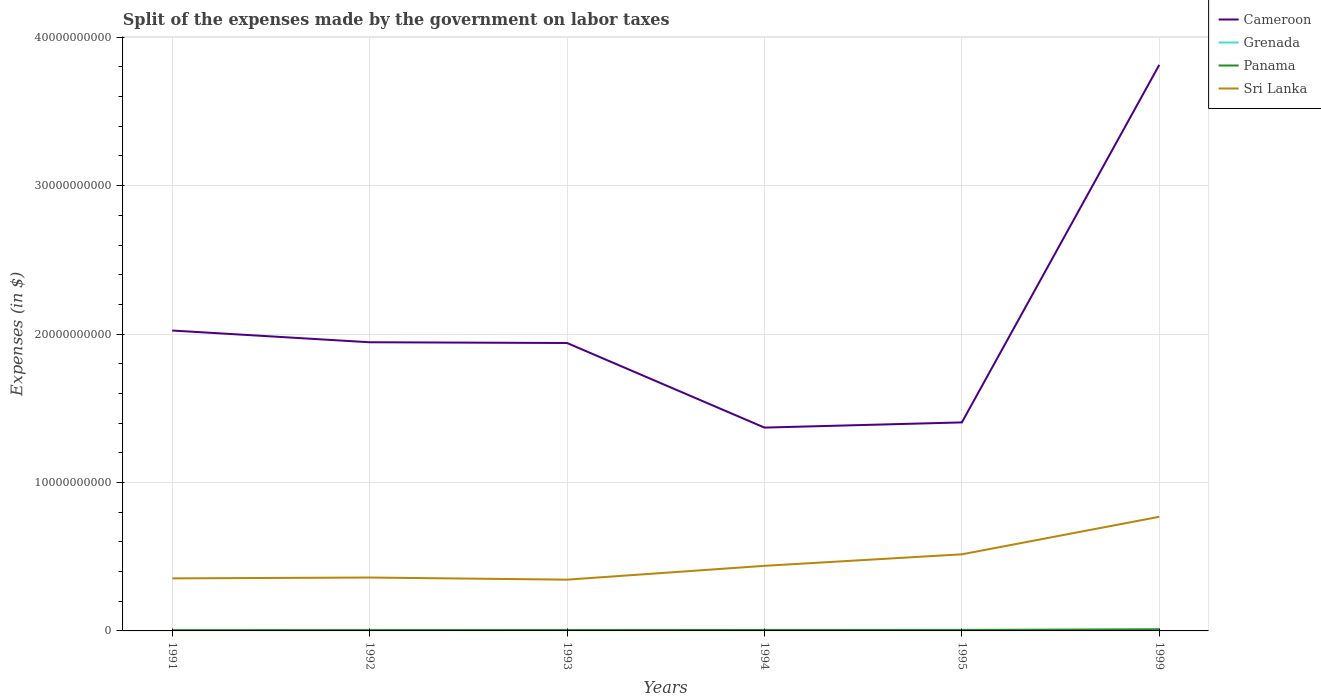How many different coloured lines are there?
Your answer should be very brief. 4. Across all years, what is the maximum expenses made by the government on labor taxes in Sri Lanka?
Your answer should be compact. 3.45e+09. What is the total expenses made by the government on labor taxes in Panama in the graph?
Give a very brief answer. -2.40e+06. What is the difference between the highest and the second highest expenses made by the government on labor taxes in Grenada?
Your response must be concise. 4.68e+06. What is the difference between the highest and the lowest expenses made by the government on labor taxes in Sri Lanka?
Provide a succinct answer. 2. How many years are there in the graph?
Your response must be concise. 6. How many legend labels are there?
Your answer should be very brief. 4. What is the title of the graph?
Offer a terse response. Split of the expenses made by the government on labor taxes. Does "Vietnam" appear as one of the legend labels in the graph?
Provide a succinct answer. No. What is the label or title of the X-axis?
Offer a very short reply. Years. What is the label or title of the Y-axis?
Provide a short and direct response. Expenses (in $). What is the Expenses (in $) in Cameroon in 1991?
Ensure brevity in your answer.  2.02e+1. What is the Expenses (in $) of Grenada in 1991?
Your answer should be compact. 6.36e+06. What is the Expenses (in $) of Panama in 1991?
Make the answer very short. 5.18e+07. What is the Expenses (in $) in Sri Lanka in 1991?
Your answer should be very brief. 3.54e+09. What is the Expenses (in $) of Cameroon in 1992?
Give a very brief answer. 1.94e+1. What is the Expenses (in $) of Grenada in 1992?
Your answer should be very brief. 5.82e+06. What is the Expenses (in $) in Panama in 1992?
Your answer should be compact. 5.61e+07. What is the Expenses (in $) of Sri Lanka in 1992?
Keep it short and to the point. 3.60e+09. What is the Expenses (in $) in Cameroon in 1993?
Your answer should be compact. 1.94e+1. What is the Expenses (in $) in Grenada in 1993?
Give a very brief answer. 8.93e+06. What is the Expenses (in $) in Panama in 1993?
Your answer should be compact. 5.89e+07. What is the Expenses (in $) in Sri Lanka in 1993?
Keep it short and to the point. 3.45e+09. What is the Expenses (in $) of Cameroon in 1994?
Keep it short and to the point. 1.37e+1. What is the Expenses (in $) of Grenada in 1994?
Ensure brevity in your answer.  9.53e+06. What is the Expenses (in $) in Panama in 1994?
Provide a succinct answer. 6.34e+07. What is the Expenses (in $) of Sri Lanka in 1994?
Provide a short and direct response. 4.39e+09. What is the Expenses (in $) in Cameroon in 1995?
Give a very brief answer. 1.40e+1. What is the Expenses (in $) in Grenada in 1995?
Keep it short and to the point. 9.49e+06. What is the Expenses (in $) in Panama in 1995?
Your response must be concise. 6.58e+07. What is the Expenses (in $) in Sri Lanka in 1995?
Give a very brief answer. 5.16e+09. What is the Expenses (in $) in Cameroon in 1999?
Make the answer very short. 3.81e+1. What is the Expenses (in $) in Grenada in 1999?
Make the answer very short. 1.05e+07. What is the Expenses (in $) in Panama in 1999?
Provide a short and direct response. 1.11e+08. What is the Expenses (in $) in Sri Lanka in 1999?
Your response must be concise. 7.69e+09. Across all years, what is the maximum Expenses (in $) of Cameroon?
Your answer should be very brief. 3.81e+1. Across all years, what is the maximum Expenses (in $) of Grenada?
Provide a short and direct response. 1.05e+07. Across all years, what is the maximum Expenses (in $) of Panama?
Your response must be concise. 1.11e+08. Across all years, what is the maximum Expenses (in $) of Sri Lanka?
Offer a terse response. 7.69e+09. Across all years, what is the minimum Expenses (in $) in Cameroon?
Your answer should be very brief. 1.37e+1. Across all years, what is the minimum Expenses (in $) of Grenada?
Make the answer very short. 5.82e+06. Across all years, what is the minimum Expenses (in $) of Panama?
Keep it short and to the point. 5.18e+07. Across all years, what is the minimum Expenses (in $) of Sri Lanka?
Make the answer very short. 3.45e+09. What is the total Expenses (in $) in Cameroon in the graph?
Provide a succinct answer. 1.25e+11. What is the total Expenses (in $) in Grenada in the graph?
Your answer should be very brief. 5.06e+07. What is the total Expenses (in $) in Panama in the graph?
Ensure brevity in your answer.  4.07e+08. What is the total Expenses (in $) in Sri Lanka in the graph?
Your response must be concise. 2.78e+1. What is the difference between the Expenses (in $) in Cameroon in 1991 and that in 1992?
Offer a very short reply. 7.90e+08. What is the difference between the Expenses (in $) in Grenada in 1991 and that in 1992?
Give a very brief answer. 5.40e+05. What is the difference between the Expenses (in $) of Panama in 1991 and that in 1992?
Your answer should be very brief. -4.30e+06. What is the difference between the Expenses (in $) of Sri Lanka in 1991 and that in 1992?
Give a very brief answer. -5.60e+07. What is the difference between the Expenses (in $) of Cameroon in 1991 and that in 1993?
Offer a terse response. 8.40e+08. What is the difference between the Expenses (in $) of Grenada in 1991 and that in 1993?
Your response must be concise. -2.57e+06. What is the difference between the Expenses (in $) of Panama in 1991 and that in 1993?
Keep it short and to the point. -7.10e+06. What is the difference between the Expenses (in $) of Sri Lanka in 1991 and that in 1993?
Make the answer very short. 8.70e+07. What is the difference between the Expenses (in $) of Cameroon in 1991 and that in 1994?
Your answer should be very brief. 6.54e+09. What is the difference between the Expenses (in $) in Grenada in 1991 and that in 1994?
Make the answer very short. -3.17e+06. What is the difference between the Expenses (in $) in Panama in 1991 and that in 1994?
Provide a succinct answer. -1.16e+07. What is the difference between the Expenses (in $) in Sri Lanka in 1991 and that in 1994?
Offer a terse response. -8.45e+08. What is the difference between the Expenses (in $) in Cameroon in 1991 and that in 1995?
Make the answer very short. 6.19e+09. What is the difference between the Expenses (in $) of Grenada in 1991 and that in 1995?
Offer a very short reply. -3.13e+06. What is the difference between the Expenses (in $) of Panama in 1991 and that in 1995?
Give a very brief answer. -1.40e+07. What is the difference between the Expenses (in $) of Sri Lanka in 1991 and that in 1995?
Make the answer very short. -1.62e+09. What is the difference between the Expenses (in $) in Cameroon in 1991 and that in 1999?
Provide a succinct answer. -1.79e+1. What is the difference between the Expenses (in $) of Grenada in 1991 and that in 1999?
Offer a terse response. -4.14e+06. What is the difference between the Expenses (in $) of Panama in 1991 and that in 1999?
Provide a succinct answer. -5.93e+07. What is the difference between the Expenses (in $) of Sri Lanka in 1991 and that in 1999?
Make the answer very short. -4.15e+09. What is the difference between the Expenses (in $) of Grenada in 1992 and that in 1993?
Make the answer very short. -3.11e+06. What is the difference between the Expenses (in $) in Panama in 1992 and that in 1993?
Make the answer very short. -2.80e+06. What is the difference between the Expenses (in $) of Sri Lanka in 1992 and that in 1993?
Provide a short and direct response. 1.43e+08. What is the difference between the Expenses (in $) of Cameroon in 1992 and that in 1994?
Give a very brief answer. 5.75e+09. What is the difference between the Expenses (in $) of Grenada in 1992 and that in 1994?
Make the answer very short. -3.71e+06. What is the difference between the Expenses (in $) of Panama in 1992 and that in 1994?
Offer a terse response. -7.30e+06. What is the difference between the Expenses (in $) in Sri Lanka in 1992 and that in 1994?
Make the answer very short. -7.89e+08. What is the difference between the Expenses (in $) of Cameroon in 1992 and that in 1995?
Provide a short and direct response. 5.40e+09. What is the difference between the Expenses (in $) of Grenada in 1992 and that in 1995?
Your response must be concise. -3.67e+06. What is the difference between the Expenses (in $) in Panama in 1992 and that in 1995?
Make the answer very short. -9.70e+06. What is the difference between the Expenses (in $) of Sri Lanka in 1992 and that in 1995?
Your answer should be compact. -1.56e+09. What is the difference between the Expenses (in $) in Cameroon in 1992 and that in 1999?
Give a very brief answer. -1.87e+1. What is the difference between the Expenses (in $) in Grenada in 1992 and that in 1999?
Keep it short and to the point. -4.68e+06. What is the difference between the Expenses (in $) of Panama in 1992 and that in 1999?
Provide a succinct answer. -5.50e+07. What is the difference between the Expenses (in $) of Sri Lanka in 1992 and that in 1999?
Make the answer very short. -4.09e+09. What is the difference between the Expenses (in $) of Cameroon in 1993 and that in 1994?
Keep it short and to the point. 5.70e+09. What is the difference between the Expenses (in $) in Grenada in 1993 and that in 1994?
Make the answer very short. -6.00e+05. What is the difference between the Expenses (in $) of Panama in 1993 and that in 1994?
Offer a very short reply. -4.50e+06. What is the difference between the Expenses (in $) in Sri Lanka in 1993 and that in 1994?
Ensure brevity in your answer.  -9.32e+08. What is the difference between the Expenses (in $) in Cameroon in 1993 and that in 1995?
Provide a short and direct response. 5.35e+09. What is the difference between the Expenses (in $) of Grenada in 1993 and that in 1995?
Keep it short and to the point. -5.60e+05. What is the difference between the Expenses (in $) in Panama in 1993 and that in 1995?
Ensure brevity in your answer.  -6.90e+06. What is the difference between the Expenses (in $) in Sri Lanka in 1993 and that in 1995?
Your answer should be compact. -1.71e+09. What is the difference between the Expenses (in $) of Cameroon in 1993 and that in 1999?
Your answer should be very brief. -1.87e+1. What is the difference between the Expenses (in $) of Grenada in 1993 and that in 1999?
Provide a short and direct response. -1.57e+06. What is the difference between the Expenses (in $) of Panama in 1993 and that in 1999?
Provide a short and direct response. -5.22e+07. What is the difference between the Expenses (in $) of Sri Lanka in 1993 and that in 1999?
Your answer should be very brief. -4.24e+09. What is the difference between the Expenses (in $) in Cameroon in 1994 and that in 1995?
Keep it short and to the point. -3.50e+08. What is the difference between the Expenses (in $) in Panama in 1994 and that in 1995?
Offer a terse response. -2.40e+06. What is the difference between the Expenses (in $) of Sri Lanka in 1994 and that in 1995?
Offer a terse response. -7.76e+08. What is the difference between the Expenses (in $) in Cameroon in 1994 and that in 1999?
Ensure brevity in your answer.  -2.44e+1. What is the difference between the Expenses (in $) in Grenada in 1994 and that in 1999?
Your answer should be very brief. -9.70e+05. What is the difference between the Expenses (in $) in Panama in 1994 and that in 1999?
Your answer should be very brief. -4.77e+07. What is the difference between the Expenses (in $) in Sri Lanka in 1994 and that in 1999?
Provide a succinct answer. -3.30e+09. What is the difference between the Expenses (in $) in Cameroon in 1995 and that in 1999?
Your answer should be very brief. -2.41e+1. What is the difference between the Expenses (in $) in Grenada in 1995 and that in 1999?
Offer a terse response. -1.01e+06. What is the difference between the Expenses (in $) of Panama in 1995 and that in 1999?
Your response must be concise. -4.53e+07. What is the difference between the Expenses (in $) of Sri Lanka in 1995 and that in 1999?
Your response must be concise. -2.53e+09. What is the difference between the Expenses (in $) in Cameroon in 1991 and the Expenses (in $) in Grenada in 1992?
Offer a very short reply. 2.02e+1. What is the difference between the Expenses (in $) in Cameroon in 1991 and the Expenses (in $) in Panama in 1992?
Provide a succinct answer. 2.02e+1. What is the difference between the Expenses (in $) of Cameroon in 1991 and the Expenses (in $) of Sri Lanka in 1992?
Ensure brevity in your answer.  1.66e+1. What is the difference between the Expenses (in $) in Grenada in 1991 and the Expenses (in $) in Panama in 1992?
Keep it short and to the point. -4.97e+07. What is the difference between the Expenses (in $) in Grenada in 1991 and the Expenses (in $) in Sri Lanka in 1992?
Your answer should be compact. -3.59e+09. What is the difference between the Expenses (in $) in Panama in 1991 and the Expenses (in $) in Sri Lanka in 1992?
Your response must be concise. -3.55e+09. What is the difference between the Expenses (in $) in Cameroon in 1991 and the Expenses (in $) in Grenada in 1993?
Keep it short and to the point. 2.02e+1. What is the difference between the Expenses (in $) of Cameroon in 1991 and the Expenses (in $) of Panama in 1993?
Your response must be concise. 2.02e+1. What is the difference between the Expenses (in $) in Cameroon in 1991 and the Expenses (in $) in Sri Lanka in 1993?
Offer a very short reply. 1.68e+1. What is the difference between the Expenses (in $) in Grenada in 1991 and the Expenses (in $) in Panama in 1993?
Offer a terse response. -5.25e+07. What is the difference between the Expenses (in $) in Grenada in 1991 and the Expenses (in $) in Sri Lanka in 1993?
Keep it short and to the point. -3.45e+09. What is the difference between the Expenses (in $) in Panama in 1991 and the Expenses (in $) in Sri Lanka in 1993?
Provide a succinct answer. -3.40e+09. What is the difference between the Expenses (in $) in Cameroon in 1991 and the Expenses (in $) in Grenada in 1994?
Your answer should be very brief. 2.02e+1. What is the difference between the Expenses (in $) in Cameroon in 1991 and the Expenses (in $) in Panama in 1994?
Make the answer very short. 2.02e+1. What is the difference between the Expenses (in $) in Cameroon in 1991 and the Expenses (in $) in Sri Lanka in 1994?
Make the answer very short. 1.59e+1. What is the difference between the Expenses (in $) of Grenada in 1991 and the Expenses (in $) of Panama in 1994?
Make the answer very short. -5.70e+07. What is the difference between the Expenses (in $) in Grenada in 1991 and the Expenses (in $) in Sri Lanka in 1994?
Give a very brief answer. -4.38e+09. What is the difference between the Expenses (in $) of Panama in 1991 and the Expenses (in $) of Sri Lanka in 1994?
Ensure brevity in your answer.  -4.33e+09. What is the difference between the Expenses (in $) of Cameroon in 1991 and the Expenses (in $) of Grenada in 1995?
Ensure brevity in your answer.  2.02e+1. What is the difference between the Expenses (in $) of Cameroon in 1991 and the Expenses (in $) of Panama in 1995?
Give a very brief answer. 2.02e+1. What is the difference between the Expenses (in $) in Cameroon in 1991 and the Expenses (in $) in Sri Lanka in 1995?
Give a very brief answer. 1.51e+1. What is the difference between the Expenses (in $) in Grenada in 1991 and the Expenses (in $) in Panama in 1995?
Your response must be concise. -5.94e+07. What is the difference between the Expenses (in $) of Grenada in 1991 and the Expenses (in $) of Sri Lanka in 1995?
Your answer should be compact. -5.16e+09. What is the difference between the Expenses (in $) of Panama in 1991 and the Expenses (in $) of Sri Lanka in 1995?
Ensure brevity in your answer.  -5.11e+09. What is the difference between the Expenses (in $) of Cameroon in 1991 and the Expenses (in $) of Grenada in 1999?
Your answer should be very brief. 2.02e+1. What is the difference between the Expenses (in $) in Cameroon in 1991 and the Expenses (in $) in Panama in 1999?
Keep it short and to the point. 2.01e+1. What is the difference between the Expenses (in $) of Cameroon in 1991 and the Expenses (in $) of Sri Lanka in 1999?
Provide a succinct answer. 1.26e+1. What is the difference between the Expenses (in $) of Grenada in 1991 and the Expenses (in $) of Panama in 1999?
Your answer should be compact. -1.05e+08. What is the difference between the Expenses (in $) in Grenada in 1991 and the Expenses (in $) in Sri Lanka in 1999?
Keep it short and to the point. -7.68e+09. What is the difference between the Expenses (in $) of Panama in 1991 and the Expenses (in $) of Sri Lanka in 1999?
Your answer should be very brief. -7.64e+09. What is the difference between the Expenses (in $) in Cameroon in 1992 and the Expenses (in $) in Grenada in 1993?
Ensure brevity in your answer.  1.94e+1. What is the difference between the Expenses (in $) in Cameroon in 1992 and the Expenses (in $) in Panama in 1993?
Your answer should be very brief. 1.94e+1. What is the difference between the Expenses (in $) in Cameroon in 1992 and the Expenses (in $) in Sri Lanka in 1993?
Your response must be concise. 1.60e+1. What is the difference between the Expenses (in $) in Grenada in 1992 and the Expenses (in $) in Panama in 1993?
Your answer should be compact. -5.31e+07. What is the difference between the Expenses (in $) in Grenada in 1992 and the Expenses (in $) in Sri Lanka in 1993?
Your response must be concise. -3.45e+09. What is the difference between the Expenses (in $) in Panama in 1992 and the Expenses (in $) in Sri Lanka in 1993?
Make the answer very short. -3.40e+09. What is the difference between the Expenses (in $) of Cameroon in 1992 and the Expenses (in $) of Grenada in 1994?
Your answer should be very brief. 1.94e+1. What is the difference between the Expenses (in $) in Cameroon in 1992 and the Expenses (in $) in Panama in 1994?
Provide a succinct answer. 1.94e+1. What is the difference between the Expenses (in $) of Cameroon in 1992 and the Expenses (in $) of Sri Lanka in 1994?
Make the answer very short. 1.51e+1. What is the difference between the Expenses (in $) in Grenada in 1992 and the Expenses (in $) in Panama in 1994?
Keep it short and to the point. -5.76e+07. What is the difference between the Expenses (in $) of Grenada in 1992 and the Expenses (in $) of Sri Lanka in 1994?
Give a very brief answer. -4.38e+09. What is the difference between the Expenses (in $) in Panama in 1992 and the Expenses (in $) in Sri Lanka in 1994?
Give a very brief answer. -4.33e+09. What is the difference between the Expenses (in $) of Cameroon in 1992 and the Expenses (in $) of Grenada in 1995?
Your answer should be compact. 1.94e+1. What is the difference between the Expenses (in $) in Cameroon in 1992 and the Expenses (in $) in Panama in 1995?
Provide a short and direct response. 1.94e+1. What is the difference between the Expenses (in $) in Cameroon in 1992 and the Expenses (in $) in Sri Lanka in 1995?
Your answer should be compact. 1.43e+1. What is the difference between the Expenses (in $) of Grenada in 1992 and the Expenses (in $) of Panama in 1995?
Your answer should be compact. -6.00e+07. What is the difference between the Expenses (in $) in Grenada in 1992 and the Expenses (in $) in Sri Lanka in 1995?
Give a very brief answer. -5.16e+09. What is the difference between the Expenses (in $) in Panama in 1992 and the Expenses (in $) in Sri Lanka in 1995?
Provide a succinct answer. -5.11e+09. What is the difference between the Expenses (in $) of Cameroon in 1992 and the Expenses (in $) of Grenada in 1999?
Keep it short and to the point. 1.94e+1. What is the difference between the Expenses (in $) in Cameroon in 1992 and the Expenses (in $) in Panama in 1999?
Make the answer very short. 1.93e+1. What is the difference between the Expenses (in $) in Cameroon in 1992 and the Expenses (in $) in Sri Lanka in 1999?
Keep it short and to the point. 1.18e+1. What is the difference between the Expenses (in $) in Grenada in 1992 and the Expenses (in $) in Panama in 1999?
Make the answer very short. -1.05e+08. What is the difference between the Expenses (in $) of Grenada in 1992 and the Expenses (in $) of Sri Lanka in 1999?
Provide a succinct answer. -7.68e+09. What is the difference between the Expenses (in $) of Panama in 1992 and the Expenses (in $) of Sri Lanka in 1999?
Keep it short and to the point. -7.63e+09. What is the difference between the Expenses (in $) of Cameroon in 1993 and the Expenses (in $) of Grenada in 1994?
Offer a terse response. 1.94e+1. What is the difference between the Expenses (in $) of Cameroon in 1993 and the Expenses (in $) of Panama in 1994?
Provide a short and direct response. 1.93e+1. What is the difference between the Expenses (in $) in Cameroon in 1993 and the Expenses (in $) in Sri Lanka in 1994?
Offer a terse response. 1.50e+1. What is the difference between the Expenses (in $) in Grenada in 1993 and the Expenses (in $) in Panama in 1994?
Provide a short and direct response. -5.45e+07. What is the difference between the Expenses (in $) in Grenada in 1993 and the Expenses (in $) in Sri Lanka in 1994?
Your answer should be very brief. -4.38e+09. What is the difference between the Expenses (in $) in Panama in 1993 and the Expenses (in $) in Sri Lanka in 1994?
Your response must be concise. -4.33e+09. What is the difference between the Expenses (in $) in Cameroon in 1993 and the Expenses (in $) in Grenada in 1995?
Your answer should be compact. 1.94e+1. What is the difference between the Expenses (in $) of Cameroon in 1993 and the Expenses (in $) of Panama in 1995?
Provide a short and direct response. 1.93e+1. What is the difference between the Expenses (in $) in Cameroon in 1993 and the Expenses (in $) in Sri Lanka in 1995?
Offer a very short reply. 1.42e+1. What is the difference between the Expenses (in $) of Grenada in 1993 and the Expenses (in $) of Panama in 1995?
Keep it short and to the point. -5.69e+07. What is the difference between the Expenses (in $) of Grenada in 1993 and the Expenses (in $) of Sri Lanka in 1995?
Give a very brief answer. -5.15e+09. What is the difference between the Expenses (in $) in Panama in 1993 and the Expenses (in $) in Sri Lanka in 1995?
Provide a succinct answer. -5.10e+09. What is the difference between the Expenses (in $) in Cameroon in 1993 and the Expenses (in $) in Grenada in 1999?
Make the answer very short. 1.94e+1. What is the difference between the Expenses (in $) in Cameroon in 1993 and the Expenses (in $) in Panama in 1999?
Provide a succinct answer. 1.93e+1. What is the difference between the Expenses (in $) of Cameroon in 1993 and the Expenses (in $) of Sri Lanka in 1999?
Provide a succinct answer. 1.17e+1. What is the difference between the Expenses (in $) in Grenada in 1993 and the Expenses (in $) in Panama in 1999?
Ensure brevity in your answer.  -1.02e+08. What is the difference between the Expenses (in $) in Grenada in 1993 and the Expenses (in $) in Sri Lanka in 1999?
Your answer should be very brief. -7.68e+09. What is the difference between the Expenses (in $) of Panama in 1993 and the Expenses (in $) of Sri Lanka in 1999?
Offer a terse response. -7.63e+09. What is the difference between the Expenses (in $) in Cameroon in 1994 and the Expenses (in $) in Grenada in 1995?
Your answer should be very brief. 1.37e+1. What is the difference between the Expenses (in $) of Cameroon in 1994 and the Expenses (in $) of Panama in 1995?
Provide a succinct answer. 1.36e+1. What is the difference between the Expenses (in $) of Cameroon in 1994 and the Expenses (in $) of Sri Lanka in 1995?
Offer a very short reply. 8.54e+09. What is the difference between the Expenses (in $) of Grenada in 1994 and the Expenses (in $) of Panama in 1995?
Your answer should be very brief. -5.63e+07. What is the difference between the Expenses (in $) of Grenada in 1994 and the Expenses (in $) of Sri Lanka in 1995?
Keep it short and to the point. -5.15e+09. What is the difference between the Expenses (in $) of Panama in 1994 and the Expenses (in $) of Sri Lanka in 1995?
Give a very brief answer. -5.10e+09. What is the difference between the Expenses (in $) in Cameroon in 1994 and the Expenses (in $) in Grenada in 1999?
Provide a short and direct response. 1.37e+1. What is the difference between the Expenses (in $) in Cameroon in 1994 and the Expenses (in $) in Panama in 1999?
Your response must be concise. 1.36e+1. What is the difference between the Expenses (in $) of Cameroon in 1994 and the Expenses (in $) of Sri Lanka in 1999?
Give a very brief answer. 6.01e+09. What is the difference between the Expenses (in $) of Grenada in 1994 and the Expenses (in $) of Panama in 1999?
Your answer should be compact. -1.02e+08. What is the difference between the Expenses (in $) of Grenada in 1994 and the Expenses (in $) of Sri Lanka in 1999?
Provide a short and direct response. -7.68e+09. What is the difference between the Expenses (in $) of Panama in 1994 and the Expenses (in $) of Sri Lanka in 1999?
Give a very brief answer. -7.63e+09. What is the difference between the Expenses (in $) in Cameroon in 1995 and the Expenses (in $) in Grenada in 1999?
Your answer should be compact. 1.40e+1. What is the difference between the Expenses (in $) in Cameroon in 1995 and the Expenses (in $) in Panama in 1999?
Give a very brief answer. 1.39e+1. What is the difference between the Expenses (in $) in Cameroon in 1995 and the Expenses (in $) in Sri Lanka in 1999?
Your response must be concise. 6.36e+09. What is the difference between the Expenses (in $) of Grenada in 1995 and the Expenses (in $) of Panama in 1999?
Offer a terse response. -1.02e+08. What is the difference between the Expenses (in $) in Grenada in 1995 and the Expenses (in $) in Sri Lanka in 1999?
Give a very brief answer. -7.68e+09. What is the difference between the Expenses (in $) of Panama in 1995 and the Expenses (in $) of Sri Lanka in 1999?
Your answer should be compact. -7.62e+09. What is the average Expenses (in $) of Cameroon per year?
Your response must be concise. 2.08e+1. What is the average Expenses (in $) in Grenada per year?
Offer a very short reply. 8.44e+06. What is the average Expenses (in $) in Panama per year?
Your answer should be very brief. 6.78e+07. What is the average Expenses (in $) of Sri Lanka per year?
Your answer should be very brief. 4.64e+09. In the year 1991, what is the difference between the Expenses (in $) in Cameroon and Expenses (in $) in Grenada?
Make the answer very short. 2.02e+1. In the year 1991, what is the difference between the Expenses (in $) in Cameroon and Expenses (in $) in Panama?
Your answer should be very brief. 2.02e+1. In the year 1991, what is the difference between the Expenses (in $) of Cameroon and Expenses (in $) of Sri Lanka?
Ensure brevity in your answer.  1.67e+1. In the year 1991, what is the difference between the Expenses (in $) in Grenada and Expenses (in $) in Panama?
Make the answer very short. -4.54e+07. In the year 1991, what is the difference between the Expenses (in $) in Grenada and Expenses (in $) in Sri Lanka?
Your answer should be very brief. -3.53e+09. In the year 1991, what is the difference between the Expenses (in $) in Panama and Expenses (in $) in Sri Lanka?
Your answer should be compact. -3.49e+09. In the year 1992, what is the difference between the Expenses (in $) in Cameroon and Expenses (in $) in Grenada?
Ensure brevity in your answer.  1.94e+1. In the year 1992, what is the difference between the Expenses (in $) in Cameroon and Expenses (in $) in Panama?
Your answer should be very brief. 1.94e+1. In the year 1992, what is the difference between the Expenses (in $) in Cameroon and Expenses (in $) in Sri Lanka?
Keep it short and to the point. 1.59e+1. In the year 1992, what is the difference between the Expenses (in $) in Grenada and Expenses (in $) in Panama?
Your answer should be very brief. -5.03e+07. In the year 1992, what is the difference between the Expenses (in $) in Grenada and Expenses (in $) in Sri Lanka?
Ensure brevity in your answer.  -3.59e+09. In the year 1992, what is the difference between the Expenses (in $) in Panama and Expenses (in $) in Sri Lanka?
Keep it short and to the point. -3.54e+09. In the year 1993, what is the difference between the Expenses (in $) of Cameroon and Expenses (in $) of Grenada?
Give a very brief answer. 1.94e+1. In the year 1993, what is the difference between the Expenses (in $) in Cameroon and Expenses (in $) in Panama?
Give a very brief answer. 1.93e+1. In the year 1993, what is the difference between the Expenses (in $) of Cameroon and Expenses (in $) of Sri Lanka?
Ensure brevity in your answer.  1.59e+1. In the year 1993, what is the difference between the Expenses (in $) in Grenada and Expenses (in $) in Panama?
Make the answer very short. -5.00e+07. In the year 1993, what is the difference between the Expenses (in $) of Grenada and Expenses (in $) of Sri Lanka?
Give a very brief answer. -3.45e+09. In the year 1993, what is the difference between the Expenses (in $) in Panama and Expenses (in $) in Sri Lanka?
Offer a terse response. -3.40e+09. In the year 1994, what is the difference between the Expenses (in $) of Cameroon and Expenses (in $) of Grenada?
Make the answer very short. 1.37e+1. In the year 1994, what is the difference between the Expenses (in $) in Cameroon and Expenses (in $) in Panama?
Provide a succinct answer. 1.36e+1. In the year 1994, what is the difference between the Expenses (in $) of Cameroon and Expenses (in $) of Sri Lanka?
Ensure brevity in your answer.  9.31e+09. In the year 1994, what is the difference between the Expenses (in $) of Grenada and Expenses (in $) of Panama?
Your response must be concise. -5.39e+07. In the year 1994, what is the difference between the Expenses (in $) in Grenada and Expenses (in $) in Sri Lanka?
Offer a very short reply. -4.38e+09. In the year 1994, what is the difference between the Expenses (in $) in Panama and Expenses (in $) in Sri Lanka?
Offer a terse response. -4.32e+09. In the year 1995, what is the difference between the Expenses (in $) of Cameroon and Expenses (in $) of Grenada?
Ensure brevity in your answer.  1.40e+1. In the year 1995, what is the difference between the Expenses (in $) in Cameroon and Expenses (in $) in Panama?
Offer a very short reply. 1.40e+1. In the year 1995, what is the difference between the Expenses (in $) in Cameroon and Expenses (in $) in Sri Lanka?
Keep it short and to the point. 8.89e+09. In the year 1995, what is the difference between the Expenses (in $) in Grenada and Expenses (in $) in Panama?
Offer a terse response. -5.63e+07. In the year 1995, what is the difference between the Expenses (in $) in Grenada and Expenses (in $) in Sri Lanka?
Offer a terse response. -5.15e+09. In the year 1995, what is the difference between the Expenses (in $) of Panama and Expenses (in $) of Sri Lanka?
Offer a terse response. -5.10e+09. In the year 1999, what is the difference between the Expenses (in $) in Cameroon and Expenses (in $) in Grenada?
Your answer should be compact. 3.81e+1. In the year 1999, what is the difference between the Expenses (in $) in Cameroon and Expenses (in $) in Panama?
Offer a very short reply. 3.80e+1. In the year 1999, what is the difference between the Expenses (in $) of Cameroon and Expenses (in $) of Sri Lanka?
Make the answer very short. 3.04e+1. In the year 1999, what is the difference between the Expenses (in $) of Grenada and Expenses (in $) of Panama?
Your answer should be very brief. -1.01e+08. In the year 1999, what is the difference between the Expenses (in $) in Grenada and Expenses (in $) in Sri Lanka?
Provide a short and direct response. -7.68e+09. In the year 1999, what is the difference between the Expenses (in $) of Panama and Expenses (in $) of Sri Lanka?
Make the answer very short. -7.58e+09. What is the ratio of the Expenses (in $) of Cameroon in 1991 to that in 1992?
Your response must be concise. 1.04. What is the ratio of the Expenses (in $) in Grenada in 1991 to that in 1992?
Provide a succinct answer. 1.09. What is the ratio of the Expenses (in $) of Panama in 1991 to that in 1992?
Your answer should be very brief. 0.92. What is the ratio of the Expenses (in $) of Sri Lanka in 1991 to that in 1992?
Your response must be concise. 0.98. What is the ratio of the Expenses (in $) of Cameroon in 1991 to that in 1993?
Provide a short and direct response. 1.04. What is the ratio of the Expenses (in $) in Grenada in 1991 to that in 1993?
Give a very brief answer. 0.71. What is the ratio of the Expenses (in $) in Panama in 1991 to that in 1993?
Your response must be concise. 0.88. What is the ratio of the Expenses (in $) of Sri Lanka in 1991 to that in 1993?
Your answer should be very brief. 1.03. What is the ratio of the Expenses (in $) in Cameroon in 1991 to that in 1994?
Your answer should be very brief. 1.48. What is the ratio of the Expenses (in $) in Grenada in 1991 to that in 1994?
Offer a very short reply. 0.67. What is the ratio of the Expenses (in $) in Panama in 1991 to that in 1994?
Offer a terse response. 0.82. What is the ratio of the Expenses (in $) in Sri Lanka in 1991 to that in 1994?
Your answer should be compact. 0.81. What is the ratio of the Expenses (in $) in Cameroon in 1991 to that in 1995?
Make the answer very short. 1.44. What is the ratio of the Expenses (in $) of Grenada in 1991 to that in 1995?
Provide a short and direct response. 0.67. What is the ratio of the Expenses (in $) of Panama in 1991 to that in 1995?
Your response must be concise. 0.79. What is the ratio of the Expenses (in $) of Sri Lanka in 1991 to that in 1995?
Provide a short and direct response. 0.69. What is the ratio of the Expenses (in $) in Cameroon in 1991 to that in 1999?
Your response must be concise. 0.53. What is the ratio of the Expenses (in $) of Grenada in 1991 to that in 1999?
Keep it short and to the point. 0.61. What is the ratio of the Expenses (in $) in Panama in 1991 to that in 1999?
Your response must be concise. 0.47. What is the ratio of the Expenses (in $) in Sri Lanka in 1991 to that in 1999?
Give a very brief answer. 0.46. What is the ratio of the Expenses (in $) of Grenada in 1992 to that in 1993?
Keep it short and to the point. 0.65. What is the ratio of the Expenses (in $) of Panama in 1992 to that in 1993?
Provide a short and direct response. 0.95. What is the ratio of the Expenses (in $) in Sri Lanka in 1992 to that in 1993?
Keep it short and to the point. 1.04. What is the ratio of the Expenses (in $) of Cameroon in 1992 to that in 1994?
Ensure brevity in your answer.  1.42. What is the ratio of the Expenses (in $) in Grenada in 1992 to that in 1994?
Keep it short and to the point. 0.61. What is the ratio of the Expenses (in $) of Panama in 1992 to that in 1994?
Ensure brevity in your answer.  0.88. What is the ratio of the Expenses (in $) in Sri Lanka in 1992 to that in 1994?
Ensure brevity in your answer.  0.82. What is the ratio of the Expenses (in $) in Cameroon in 1992 to that in 1995?
Your answer should be compact. 1.38. What is the ratio of the Expenses (in $) in Grenada in 1992 to that in 1995?
Offer a terse response. 0.61. What is the ratio of the Expenses (in $) of Panama in 1992 to that in 1995?
Your response must be concise. 0.85. What is the ratio of the Expenses (in $) of Sri Lanka in 1992 to that in 1995?
Your response must be concise. 0.7. What is the ratio of the Expenses (in $) of Cameroon in 1992 to that in 1999?
Ensure brevity in your answer.  0.51. What is the ratio of the Expenses (in $) of Grenada in 1992 to that in 1999?
Give a very brief answer. 0.55. What is the ratio of the Expenses (in $) of Panama in 1992 to that in 1999?
Keep it short and to the point. 0.51. What is the ratio of the Expenses (in $) in Sri Lanka in 1992 to that in 1999?
Keep it short and to the point. 0.47. What is the ratio of the Expenses (in $) of Cameroon in 1993 to that in 1994?
Ensure brevity in your answer.  1.42. What is the ratio of the Expenses (in $) of Grenada in 1993 to that in 1994?
Offer a very short reply. 0.94. What is the ratio of the Expenses (in $) in Panama in 1993 to that in 1994?
Give a very brief answer. 0.93. What is the ratio of the Expenses (in $) in Sri Lanka in 1993 to that in 1994?
Ensure brevity in your answer.  0.79. What is the ratio of the Expenses (in $) in Cameroon in 1993 to that in 1995?
Keep it short and to the point. 1.38. What is the ratio of the Expenses (in $) of Grenada in 1993 to that in 1995?
Your answer should be very brief. 0.94. What is the ratio of the Expenses (in $) in Panama in 1993 to that in 1995?
Your answer should be very brief. 0.9. What is the ratio of the Expenses (in $) in Sri Lanka in 1993 to that in 1995?
Make the answer very short. 0.67. What is the ratio of the Expenses (in $) of Cameroon in 1993 to that in 1999?
Your answer should be very brief. 0.51. What is the ratio of the Expenses (in $) of Grenada in 1993 to that in 1999?
Give a very brief answer. 0.85. What is the ratio of the Expenses (in $) in Panama in 1993 to that in 1999?
Offer a terse response. 0.53. What is the ratio of the Expenses (in $) in Sri Lanka in 1993 to that in 1999?
Your response must be concise. 0.45. What is the ratio of the Expenses (in $) in Cameroon in 1994 to that in 1995?
Your answer should be compact. 0.98. What is the ratio of the Expenses (in $) in Panama in 1994 to that in 1995?
Provide a succinct answer. 0.96. What is the ratio of the Expenses (in $) in Sri Lanka in 1994 to that in 1995?
Provide a short and direct response. 0.85. What is the ratio of the Expenses (in $) in Cameroon in 1994 to that in 1999?
Give a very brief answer. 0.36. What is the ratio of the Expenses (in $) of Grenada in 1994 to that in 1999?
Your answer should be very brief. 0.91. What is the ratio of the Expenses (in $) of Panama in 1994 to that in 1999?
Make the answer very short. 0.57. What is the ratio of the Expenses (in $) of Sri Lanka in 1994 to that in 1999?
Offer a terse response. 0.57. What is the ratio of the Expenses (in $) in Cameroon in 1995 to that in 1999?
Your response must be concise. 0.37. What is the ratio of the Expenses (in $) in Grenada in 1995 to that in 1999?
Provide a short and direct response. 0.9. What is the ratio of the Expenses (in $) in Panama in 1995 to that in 1999?
Provide a short and direct response. 0.59. What is the ratio of the Expenses (in $) of Sri Lanka in 1995 to that in 1999?
Offer a very short reply. 0.67. What is the difference between the highest and the second highest Expenses (in $) of Cameroon?
Your answer should be compact. 1.79e+1. What is the difference between the highest and the second highest Expenses (in $) of Grenada?
Keep it short and to the point. 9.70e+05. What is the difference between the highest and the second highest Expenses (in $) in Panama?
Make the answer very short. 4.53e+07. What is the difference between the highest and the second highest Expenses (in $) of Sri Lanka?
Provide a short and direct response. 2.53e+09. What is the difference between the highest and the lowest Expenses (in $) in Cameroon?
Give a very brief answer. 2.44e+1. What is the difference between the highest and the lowest Expenses (in $) of Grenada?
Offer a very short reply. 4.68e+06. What is the difference between the highest and the lowest Expenses (in $) of Panama?
Ensure brevity in your answer.  5.93e+07. What is the difference between the highest and the lowest Expenses (in $) of Sri Lanka?
Make the answer very short. 4.24e+09. 